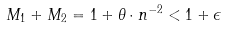Convert formula to latex. <formula><loc_0><loc_0><loc_500><loc_500>M _ { 1 } + M _ { 2 } = 1 + { \theta } \cdot { n ^ { - 2 } } < 1 + \epsilon</formula> 